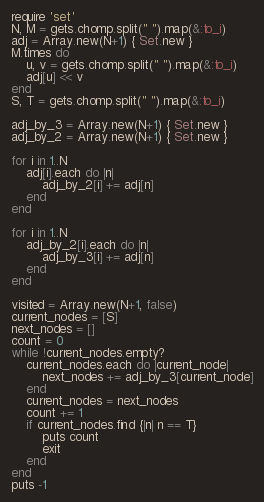<code> <loc_0><loc_0><loc_500><loc_500><_Ruby_>require 'set'
N, M = gets.chomp.split(" ").map(&:to_i)
adj = Array.new(N+1) { Set.new }
M.times do 
    u, v = gets.chomp.split(" ").map(&:to_i)
    adj[u] << v
end
S, T = gets.chomp.split(" ").map(&:to_i)

adj_by_3 = Array.new(N+1) { Set.new }
adj_by_2 = Array.new(N+1) { Set.new }

for i in 1..N
    adj[i].each do |n|
        adj_by_2[i] += adj[n]
    end
end

for i in 1..N
    adj_by_2[i].each do |n|
        adj_by_3[i] += adj[n]
    end
end

visited = Array.new(N+1, false)
current_nodes = [S]
next_nodes = []
count = 0
while !current_nodes.empty?
    current_nodes.each do |current_node|
        next_nodes += adj_by_3[current_node]
    end
    current_nodes = next_nodes
    count += 1
    if current_nodes.find {|n| n == T}
        puts count 
        exit
    end
end
puts -1</code> 